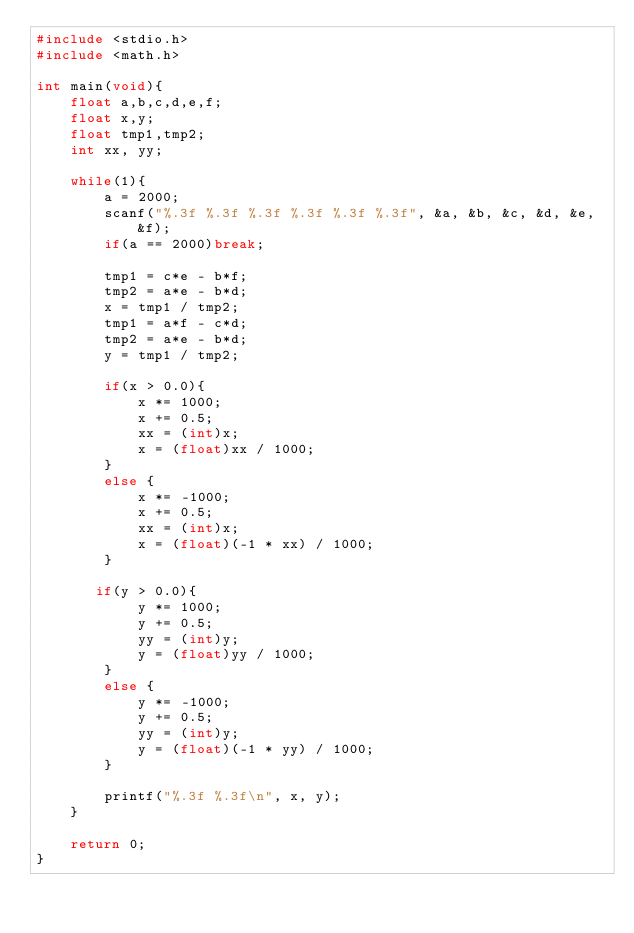<code> <loc_0><loc_0><loc_500><loc_500><_C_>#include <stdio.h>
#include <math.h>

int main(void){
    float a,b,c,d,e,f;
    float x,y;
    float tmp1,tmp2;
    int xx, yy;

    while(1){
        a = 2000;
        scanf("%.3f %.3f %.3f %.3f %.3f %.3f", &a, &b, &c, &d, &e, &f);
        if(a == 2000)break;

        tmp1 = c*e - b*f;
        tmp2 = a*e - b*d;
        x = tmp1 / tmp2;
        tmp1 = a*f - c*d;
        tmp2 = a*e - b*d;
        y = tmp1 / tmp2;
         
        if(x > 0.0){
            x *= 1000;
            x += 0.5;
            xx = (int)x;
            x = (float)xx / 1000;
        }
        else {
            x *= -1000;
            x += 0.5;
            xx = (int)x;
            x = (float)(-1 * xx) / 1000;
        }

       if(y > 0.0){
            y *= 1000;
            y += 0.5;
            yy = (int)y;
            y = (float)yy / 1000;
        }
        else {
            y *= -1000;
            y += 0.5;
            yy = (int)y;
            y = (float)(-1 * yy) / 1000;
        }

        printf("%.3f %.3f\n", x, y);
    }

    return 0;
}</code> 